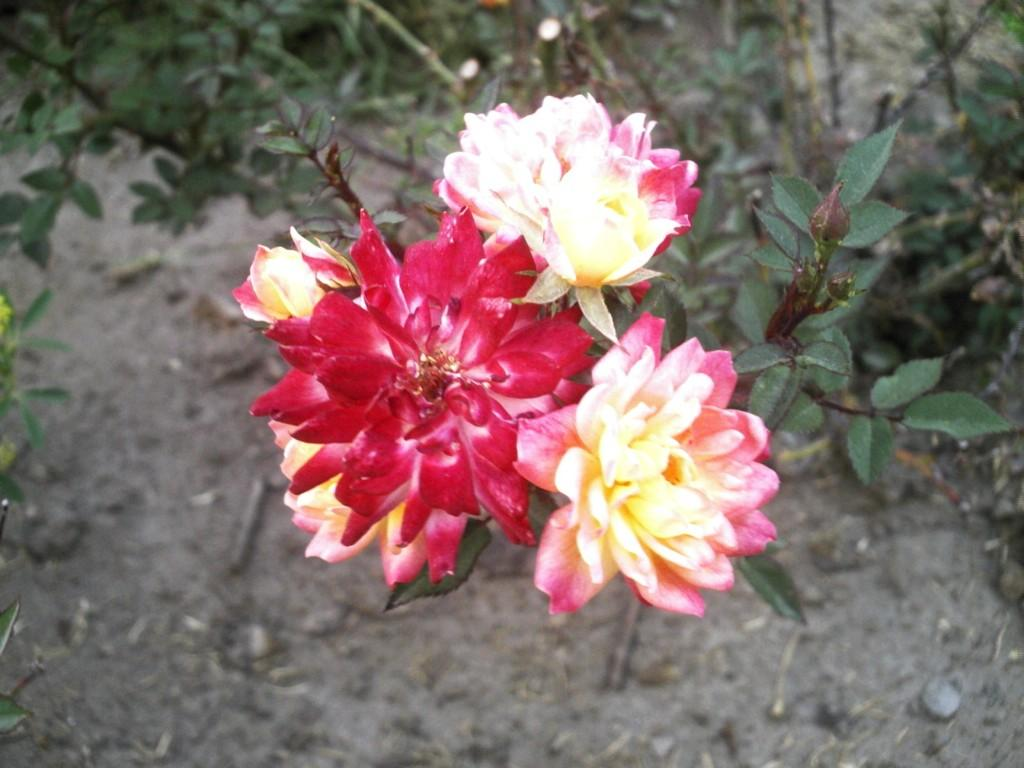What type of living organisms can be seen in the image? Flowers and plants are visible in the image. Can you describe the plants in the image? The plants in the image are not specified, but they are present alongside the flowers. How many pies are on the shelf in the image? There is no shelf or pie present in the image; it features flowers and plants. 